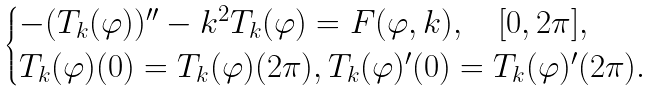Convert formula to latex. <formula><loc_0><loc_0><loc_500><loc_500>\begin{cases} - ( T _ { k } ( \varphi ) ) ^ { \prime \prime } - k ^ { 2 } T _ { k } ( \varphi ) = F ( \varphi , k ) , \quad [ 0 , 2 \pi ] , \\ T _ { k } ( \varphi ) ( 0 ) = T _ { k } ( \varphi ) ( 2 \pi ) , T _ { k } ( \varphi ) ^ { \prime } ( 0 ) = T _ { k } ( \varphi ) ^ { \prime } ( 2 \pi ) . \end{cases}</formula> 